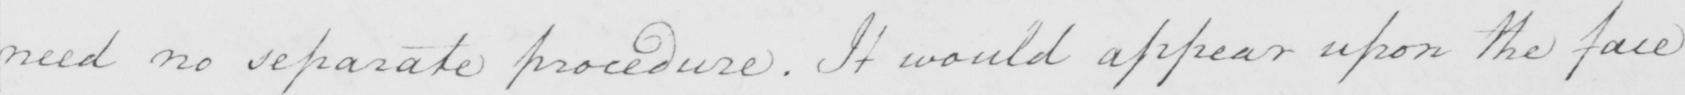Can you read and transcribe this handwriting? need no separate procedure . It would appear upon the face 